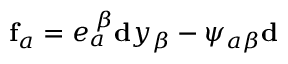Convert formula to latex. <formula><loc_0><loc_0><loc_500><loc_500>f _ { a } = e _ { a } ^ { \, \beta } d y _ { \beta } - \psi _ { a \beta } d</formula> 